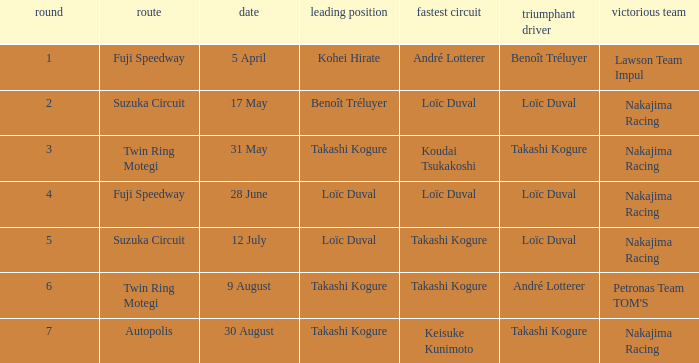Who has the fastest lap where Benoît Tréluyer got the pole position? Loïc Duval. 